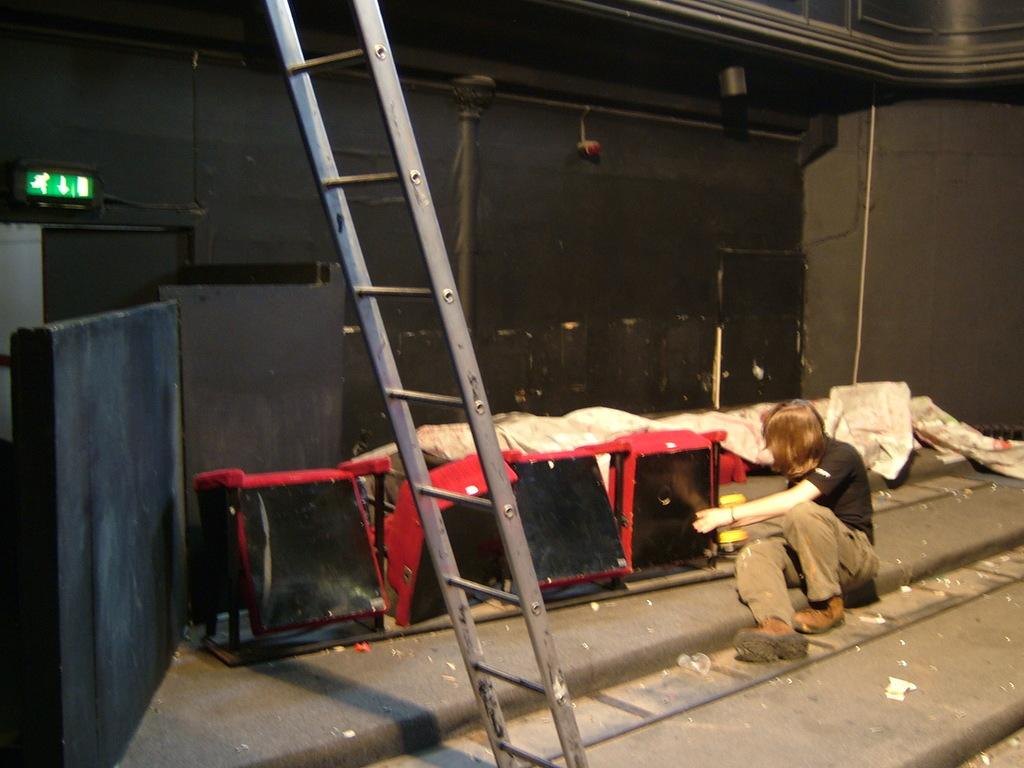What is the person in the image doing? The person is sitting on the floor in the image. What can be seen in the image besides the person? There is a ladder, a signboard, and other objects visible in the image. What is the purpose of the ladder in the image? The purpose of the ladder is not specified in the image, but it could be used for reaching higher objects or areas. What is visible in the background of the image? There is a wall visible in the background of the image. What type of dress is the ant wearing in the image? There is no ant present in the image, and therefore no such clothing can be observed. 